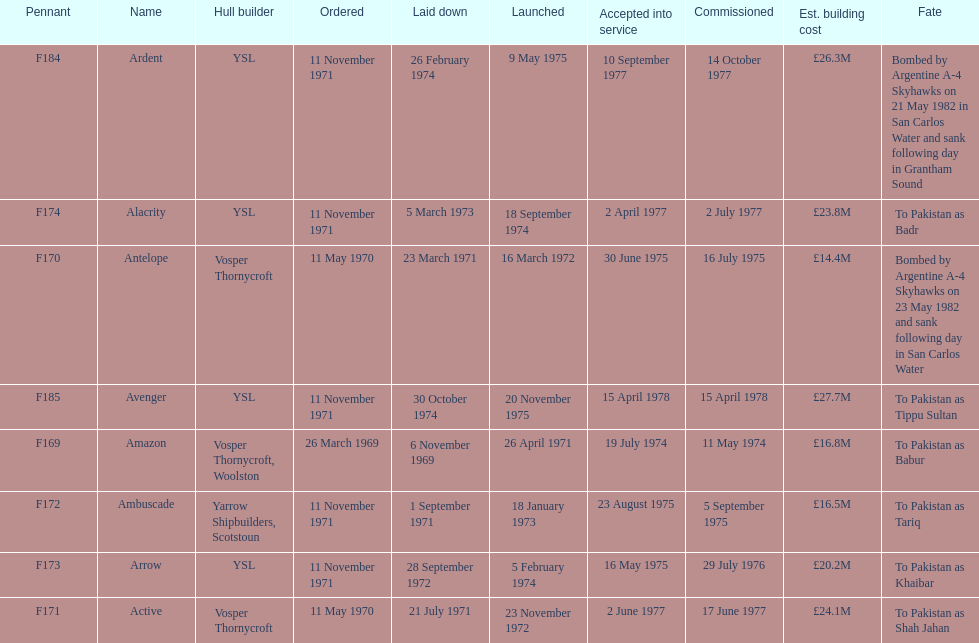I'm looking to parse the entire table for insights. Could you assist me with that? {'header': ['Pennant', 'Name', 'Hull builder', 'Ordered', 'Laid down', 'Launched', 'Accepted into service', 'Commissioned', 'Est. building cost', 'Fate'], 'rows': [['F184', 'Ardent', 'YSL', '11 November 1971', '26 February 1974', '9 May 1975', '10 September 1977', '14 October 1977', '£26.3M', 'Bombed by Argentine A-4 Skyhawks on 21 May 1982 in San Carlos Water and sank following day in Grantham Sound'], ['F174', 'Alacrity', 'YSL', '11 November 1971', '5 March 1973', '18 September 1974', '2 April 1977', '2 July 1977', '£23.8M', 'To Pakistan as Badr'], ['F170', 'Antelope', 'Vosper Thornycroft', '11 May 1970', '23 March 1971', '16 March 1972', '30 June 1975', '16 July 1975', '£14.4M', 'Bombed by Argentine A-4 Skyhawks on 23 May 1982 and sank following day in San Carlos Water'], ['F185', 'Avenger', 'YSL', '11 November 1971', '30 October 1974', '20 November 1975', '15 April 1978', '15 April 1978', '£27.7M', 'To Pakistan as Tippu Sultan'], ['F169', 'Amazon', 'Vosper Thornycroft, Woolston', '26 March 1969', '6 November 1969', '26 April 1971', '19 July 1974', '11 May 1974', '£16.8M', 'To Pakistan as Babur'], ['F172', 'Ambuscade', 'Yarrow Shipbuilders, Scotstoun', '11 November 1971', '1 September 1971', '18 January 1973', '23 August 1975', '5 September 1975', '£16.5M', 'To Pakistan as Tariq'], ['F173', 'Arrow', 'YSL', '11 November 1971', '28 September 1972', '5 February 1974', '16 May 1975', '29 July 1976', '£20.2M', 'To Pakistan as Khaibar'], ['F171', 'Active', 'Vosper Thornycroft', '11 May 1970', '21 July 1971', '23 November 1972', '2 June 1977', '17 June 1977', '£24.1M', 'To Pakistan as Shah Jahan']]} What is the name of the ship listed after ardent? Avenger. 